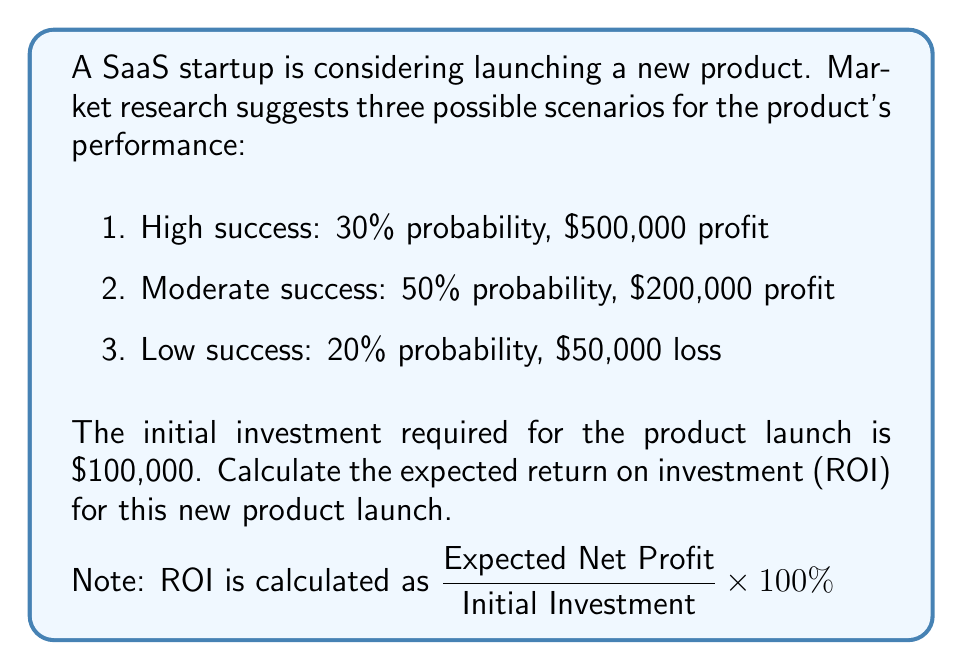Show me your answer to this math problem. Let's approach this step-by-step:

1. First, we need to calculate the expected profit:

   Expected Profit = $\sum_{i=1}^{n} P(i) \times V(i)$

   Where $P(i)$ is the probability of each scenario and $V(i)$ is the value (profit or loss) of each scenario.

   $E(\text{Profit}) = (0.30 \times \$500,000) + (0.50 \times \$200,000) + (0.20 \times (-\$50,000))$
   $= \$150,000 + \$100,000 - \$10,000$
   $= \$240,000$

2. Next, we calculate the expected net profit by subtracting the initial investment:

   Expected Net Profit = Expected Profit - Initial Investment
   $= \$240,000 - \$100,000 = \$140,000$

3. Now we can calculate the ROI:

   $ROI = \frac{\text{Expected Net Profit}}{\text{Initial Investment}} \times 100\%$

   $= \frac{\$140,000}{\$100,000} \times 100\%$
   $= 1.40 \times 100\%$
   $= 140\%$
Answer: 140% 